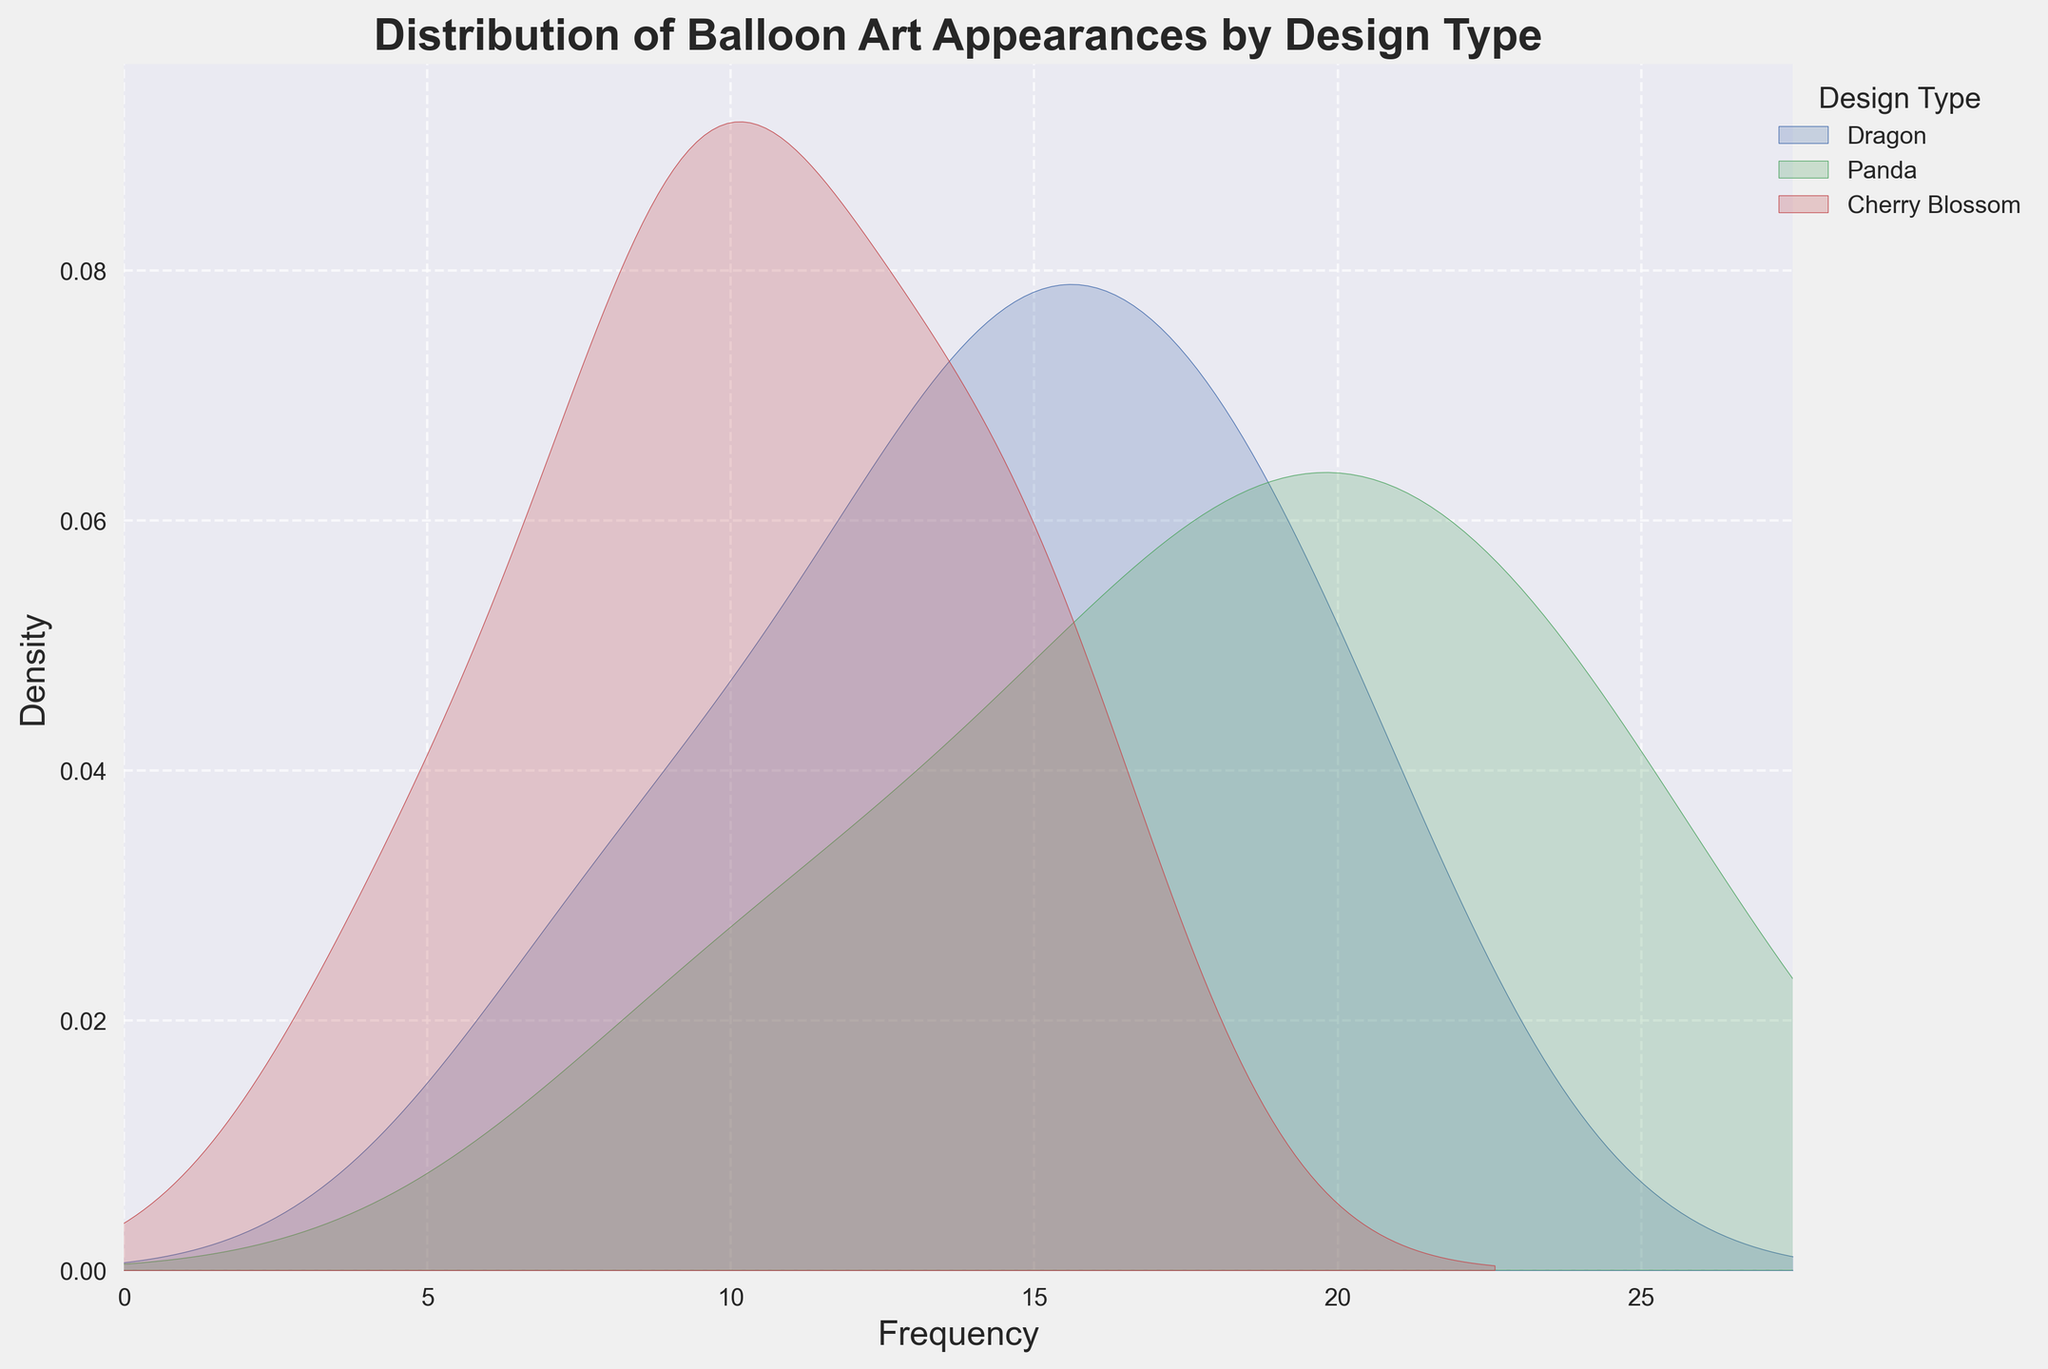What is the title of the plot? The title of the plot is typically placed at the top of the figure and gives the viewer immediate information about what the plot represents. In this instance, the title clearly indicates the specific data being visualized.
Answer: Distribution of Balloon Art Appearances by Design Type What are the labels of the x and y axes? The axis labels provide the information on what each axis of the plot represents. In this plot, the x-axis represents the frequency while the y-axis represents the density.
Answer: Frequency, Density How many design types are represented in the plot? By looking at the legend of the plot which is located on the right side, we can count the different design types listed. Each unique label corresponds to a different design type represented in the plot.
Answer: Three What is the highest frequency value observed for the 'Panda' design? To find this, we look for the peak of the curve associated with the 'Panda' design in the plot. The peaks in density plots usually correspond to the most frequent observations.
Answer: Approximately 25 Which design type shows the broadest distribution in terms of frequency? This can be observed by looking at the spread of the density curves. The broader the curve, the wider the distribution of that design type's frequency.
Answer: Dragon Which city likely has the highest frequency variability for 'Cherry Blossom'? To determine this, we analyze which city has the widest spread of frequency values for 'Cherry Blossom'. Through visual comparison, the spread of the 'Cherry Blossom' data points can be inferred.
Answer: Houston Which two design types seem to have the most similar distributions? By comparing the shapes and locations of the density curves for different design types visually, we can infer which two are more alike in terms of their distribution patterns.
Answer: Panda and Dragon What is the median frequency for the 'Dragon' design type? The median can be approximated by looking at the point where the cumulative density reaches 0.5 on the density curve for 'Dragon'.
Answer: Approximately 15 Is the cherry blossom design more common in Seattle or Chicago? To determine this, we need to compare the density estimations for the 'Cherry Blossom' design in Seattle and Chicago. The city with the higher peak density indicates more common appearances.
Answer: Seattle 